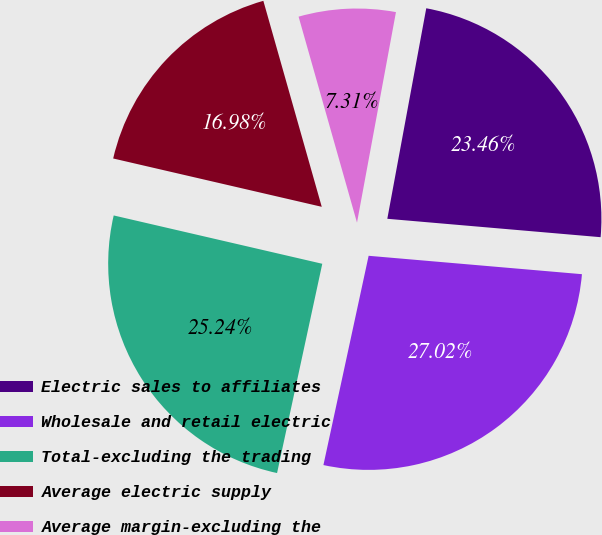Convert chart to OTSL. <chart><loc_0><loc_0><loc_500><loc_500><pie_chart><fcel>Electric sales to affiliates<fcel>Wholesale and retail electric<fcel>Total-excluding the trading<fcel>Average electric supply<fcel>Average margin-excluding the<nl><fcel>23.46%<fcel>27.02%<fcel>25.24%<fcel>16.98%<fcel>7.31%<nl></chart> 